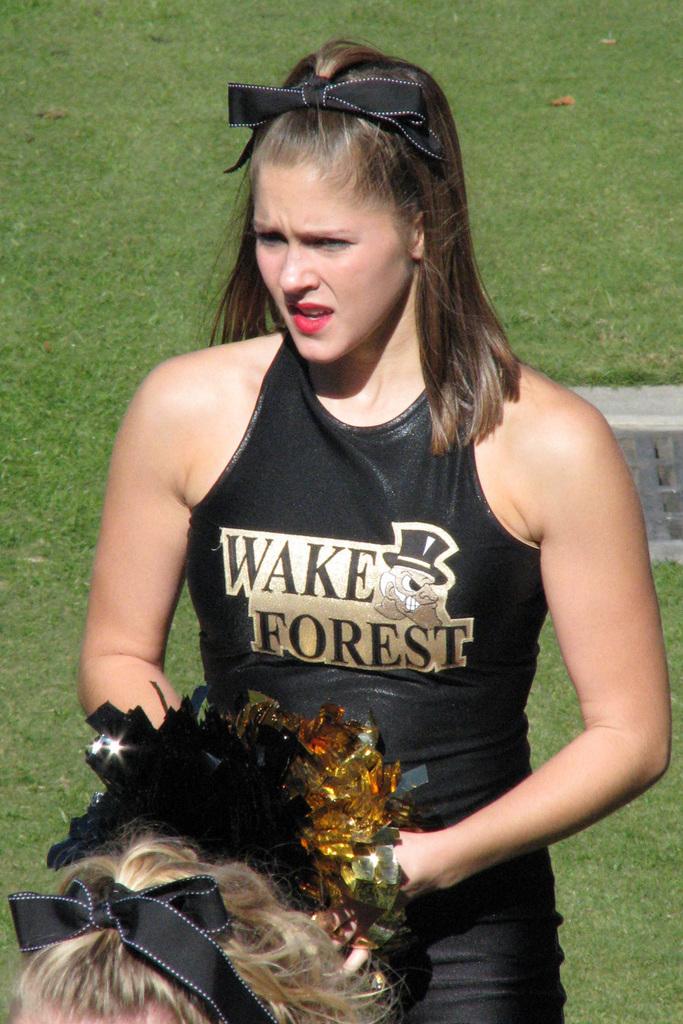What team does she cheer for?
Provide a short and direct response. Wake forest. 